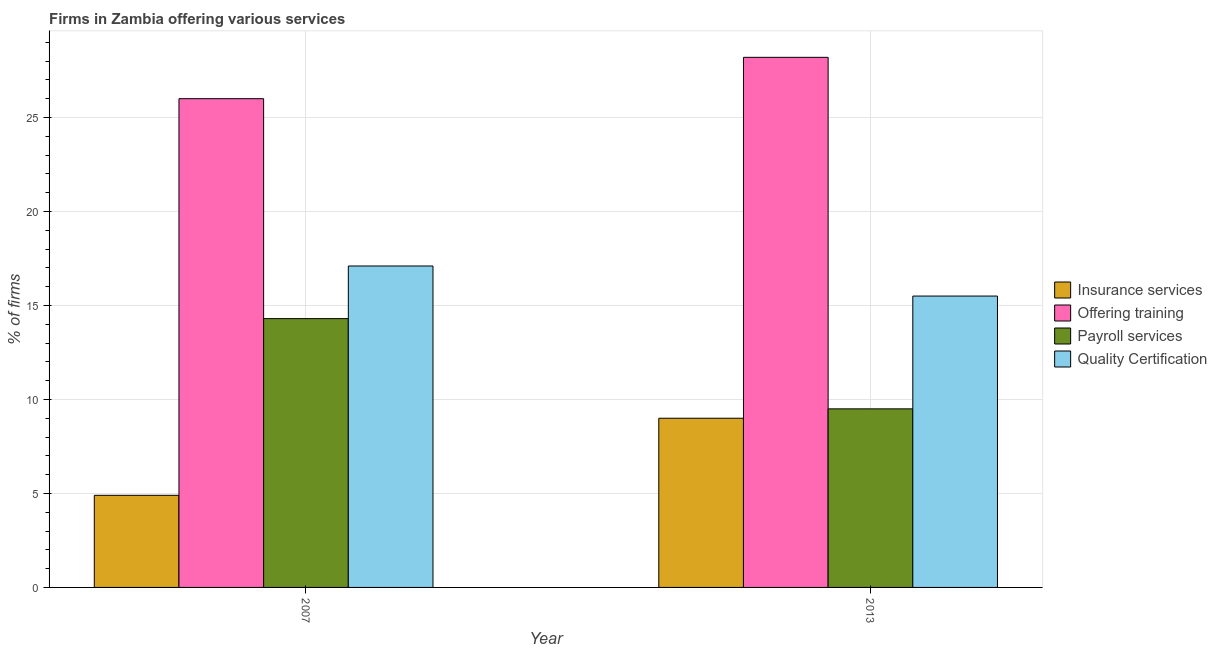Are the number of bars on each tick of the X-axis equal?
Your response must be concise. Yes. What is the label of the 1st group of bars from the left?
Provide a short and direct response. 2007. In how many cases, is the number of bars for a given year not equal to the number of legend labels?
Give a very brief answer. 0. What is the percentage of firms offering training in 2007?
Your answer should be very brief. 26. Across all years, what is the minimum percentage of firms offering quality certification?
Offer a very short reply. 15.5. In which year was the percentage of firms offering training minimum?
Offer a very short reply. 2007. What is the total percentage of firms offering training in the graph?
Your answer should be very brief. 54.2. What is the difference between the percentage of firms offering training in 2007 and that in 2013?
Offer a terse response. -2.2. What is the difference between the percentage of firms offering quality certification in 2013 and the percentage of firms offering payroll services in 2007?
Give a very brief answer. -1.6. What is the ratio of the percentage of firms offering insurance services in 2007 to that in 2013?
Your answer should be compact. 0.54. In how many years, is the percentage of firms offering insurance services greater than the average percentage of firms offering insurance services taken over all years?
Ensure brevity in your answer.  1. Is it the case that in every year, the sum of the percentage of firms offering insurance services and percentage of firms offering payroll services is greater than the sum of percentage of firms offering quality certification and percentage of firms offering training?
Provide a succinct answer. No. What does the 3rd bar from the left in 2007 represents?
Your answer should be compact. Payroll services. What does the 2nd bar from the right in 2007 represents?
Provide a short and direct response. Payroll services. What is the difference between two consecutive major ticks on the Y-axis?
Provide a succinct answer. 5. How many legend labels are there?
Offer a very short reply. 4. How are the legend labels stacked?
Give a very brief answer. Vertical. What is the title of the graph?
Make the answer very short. Firms in Zambia offering various services . Does "Secondary general education" appear as one of the legend labels in the graph?
Make the answer very short. No. What is the label or title of the Y-axis?
Your answer should be compact. % of firms. What is the % of firms of Payroll services in 2007?
Offer a very short reply. 14.3. What is the % of firms in Insurance services in 2013?
Provide a short and direct response. 9. What is the % of firms in Offering training in 2013?
Provide a short and direct response. 28.2. What is the % of firms in Quality Certification in 2013?
Ensure brevity in your answer.  15.5. Across all years, what is the maximum % of firms of Insurance services?
Offer a very short reply. 9. Across all years, what is the maximum % of firms of Offering training?
Keep it short and to the point. 28.2. What is the total % of firms of Offering training in the graph?
Your answer should be very brief. 54.2. What is the total % of firms of Payroll services in the graph?
Provide a short and direct response. 23.8. What is the total % of firms of Quality Certification in the graph?
Keep it short and to the point. 32.6. What is the difference between the % of firms of Insurance services in 2007 and that in 2013?
Make the answer very short. -4.1. What is the difference between the % of firms of Offering training in 2007 and that in 2013?
Make the answer very short. -2.2. What is the difference between the % of firms of Insurance services in 2007 and the % of firms of Offering training in 2013?
Provide a succinct answer. -23.3. What is the difference between the % of firms of Insurance services in 2007 and the % of firms of Payroll services in 2013?
Make the answer very short. -4.6. What is the difference between the % of firms of Offering training in 2007 and the % of firms of Quality Certification in 2013?
Give a very brief answer. 10.5. What is the difference between the % of firms of Payroll services in 2007 and the % of firms of Quality Certification in 2013?
Keep it short and to the point. -1.2. What is the average % of firms in Insurance services per year?
Offer a terse response. 6.95. What is the average % of firms of Offering training per year?
Give a very brief answer. 27.1. In the year 2007, what is the difference between the % of firms of Insurance services and % of firms of Offering training?
Provide a short and direct response. -21.1. In the year 2007, what is the difference between the % of firms in Insurance services and % of firms in Payroll services?
Provide a short and direct response. -9.4. In the year 2007, what is the difference between the % of firms of Insurance services and % of firms of Quality Certification?
Make the answer very short. -12.2. In the year 2007, what is the difference between the % of firms in Offering training and % of firms in Payroll services?
Provide a succinct answer. 11.7. In the year 2007, what is the difference between the % of firms in Offering training and % of firms in Quality Certification?
Offer a terse response. 8.9. In the year 2007, what is the difference between the % of firms in Payroll services and % of firms in Quality Certification?
Your answer should be very brief. -2.8. In the year 2013, what is the difference between the % of firms in Insurance services and % of firms in Offering training?
Your answer should be compact. -19.2. In the year 2013, what is the difference between the % of firms of Offering training and % of firms of Payroll services?
Your answer should be very brief. 18.7. In the year 2013, what is the difference between the % of firms in Payroll services and % of firms in Quality Certification?
Provide a short and direct response. -6. What is the ratio of the % of firms of Insurance services in 2007 to that in 2013?
Your response must be concise. 0.54. What is the ratio of the % of firms in Offering training in 2007 to that in 2013?
Give a very brief answer. 0.92. What is the ratio of the % of firms in Payroll services in 2007 to that in 2013?
Provide a succinct answer. 1.51. What is the ratio of the % of firms in Quality Certification in 2007 to that in 2013?
Keep it short and to the point. 1.1. What is the difference between the highest and the second highest % of firms in Quality Certification?
Make the answer very short. 1.6. What is the difference between the highest and the lowest % of firms of Offering training?
Give a very brief answer. 2.2. What is the difference between the highest and the lowest % of firms in Payroll services?
Offer a terse response. 4.8. What is the difference between the highest and the lowest % of firms in Quality Certification?
Give a very brief answer. 1.6. 